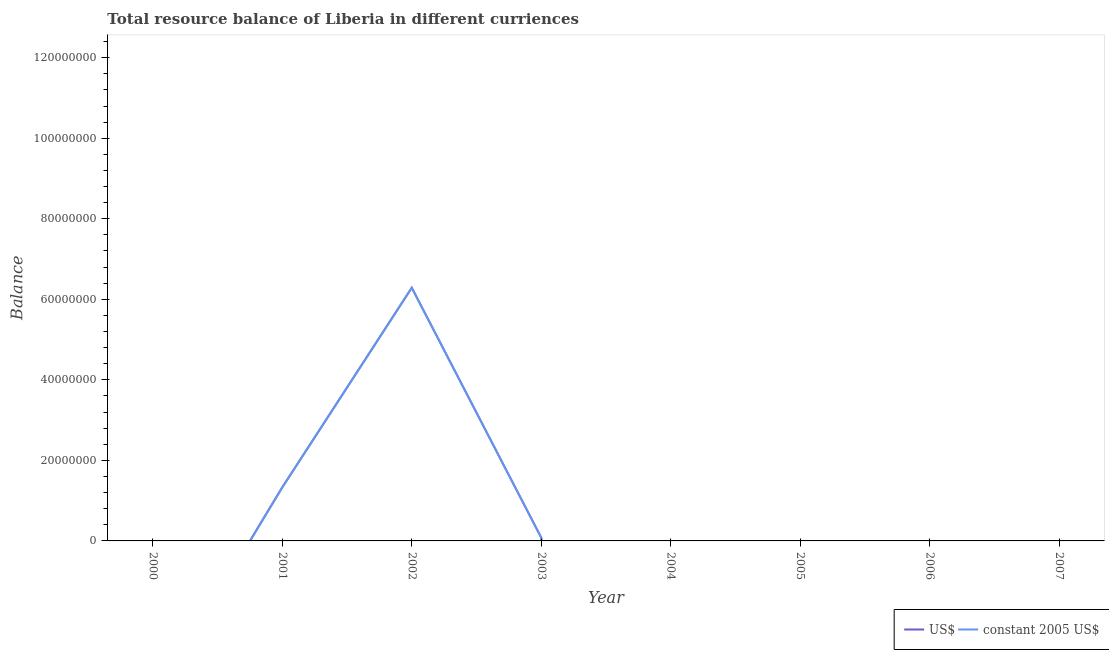Does the line corresponding to resource balance in constant us$ intersect with the line corresponding to resource balance in us$?
Provide a succinct answer. Yes. What is the resource balance in constant us$ in 2007?
Offer a very short reply. 0. Across all years, what is the maximum resource balance in constant us$?
Keep it short and to the point. 6.29e+07. In which year was the resource balance in us$ maximum?
Ensure brevity in your answer.  2002. What is the total resource balance in constant us$ in the graph?
Ensure brevity in your answer.  7.70e+07. What is the difference between the resource balance in us$ in 2001 and that in 2003?
Provide a short and direct response. 1.25e+07. What is the average resource balance in constant us$ per year?
Keep it short and to the point. 9.62e+06. In the year 2002, what is the difference between the resource balance in constant us$ and resource balance in us$?
Keep it short and to the point. 0. What is the ratio of the resource balance in constant us$ in 2002 to that in 2003?
Your answer should be very brief. 77.97. What is the difference between the highest and the second highest resource balance in constant us$?
Offer a terse response. 4.96e+07. What is the difference between the highest and the lowest resource balance in us$?
Give a very brief answer. 6.29e+07. Does the resource balance in us$ monotonically increase over the years?
Your response must be concise. No. Is the resource balance in constant us$ strictly greater than the resource balance in us$ over the years?
Your response must be concise. No. How many years are there in the graph?
Make the answer very short. 8. What is the difference between two consecutive major ticks on the Y-axis?
Offer a very short reply. 2.00e+07. Are the values on the major ticks of Y-axis written in scientific E-notation?
Provide a short and direct response. No. Does the graph contain grids?
Ensure brevity in your answer.  No. Where does the legend appear in the graph?
Your answer should be compact. Bottom right. How many legend labels are there?
Offer a very short reply. 2. What is the title of the graph?
Offer a terse response. Total resource balance of Liberia in different curriences. What is the label or title of the Y-axis?
Provide a short and direct response. Balance. What is the Balance of US$ in 2000?
Your answer should be compact. 0. What is the Balance of constant 2005 US$ in 2000?
Your answer should be compact. 0. What is the Balance in US$ in 2001?
Your answer should be compact. 1.33e+07. What is the Balance of constant 2005 US$ in 2001?
Make the answer very short. 1.33e+07. What is the Balance of US$ in 2002?
Your answer should be very brief. 6.29e+07. What is the Balance of constant 2005 US$ in 2002?
Keep it short and to the point. 6.29e+07. What is the Balance of US$ in 2003?
Your answer should be very brief. 8.06e+05. What is the Balance of constant 2005 US$ in 2003?
Ensure brevity in your answer.  8.06e+05. What is the Balance of constant 2005 US$ in 2004?
Ensure brevity in your answer.  0. What is the Balance of US$ in 2005?
Your answer should be very brief. 0. What is the Balance of constant 2005 US$ in 2005?
Your answer should be compact. 0. What is the Balance of US$ in 2006?
Your answer should be very brief. 0. What is the Balance in constant 2005 US$ in 2006?
Provide a succinct answer. 0. What is the Balance of US$ in 2007?
Your response must be concise. 0. Across all years, what is the maximum Balance of US$?
Your answer should be compact. 6.29e+07. Across all years, what is the maximum Balance of constant 2005 US$?
Give a very brief answer. 6.29e+07. What is the total Balance of US$ in the graph?
Provide a short and direct response. 7.70e+07. What is the total Balance in constant 2005 US$ in the graph?
Offer a very short reply. 7.70e+07. What is the difference between the Balance of US$ in 2001 and that in 2002?
Your response must be concise. -4.96e+07. What is the difference between the Balance of constant 2005 US$ in 2001 and that in 2002?
Offer a terse response. -4.96e+07. What is the difference between the Balance in US$ in 2001 and that in 2003?
Keep it short and to the point. 1.25e+07. What is the difference between the Balance of constant 2005 US$ in 2001 and that in 2003?
Provide a short and direct response. 1.25e+07. What is the difference between the Balance of US$ in 2002 and that in 2003?
Keep it short and to the point. 6.21e+07. What is the difference between the Balance of constant 2005 US$ in 2002 and that in 2003?
Your response must be concise. 6.21e+07. What is the difference between the Balance of US$ in 2001 and the Balance of constant 2005 US$ in 2002?
Give a very brief answer. -4.96e+07. What is the difference between the Balance of US$ in 2001 and the Balance of constant 2005 US$ in 2003?
Make the answer very short. 1.25e+07. What is the difference between the Balance of US$ in 2002 and the Balance of constant 2005 US$ in 2003?
Provide a succinct answer. 6.21e+07. What is the average Balance in US$ per year?
Offer a very short reply. 9.62e+06. What is the average Balance in constant 2005 US$ per year?
Keep it short and to the point. 9.62e+06. In the year 2001, what is the difference between the Balance of US$ and Balance of constant 2005 US$?
Provide a short and direct response. 0. In the year 2003, what is the difference between the Balance in US$ and Balance in constant 2005 US$?
Provide a succinct answer. 0. What is the ratio of the Balance of US$ in 2001 to that in 2002?
Ensure brevity in your answer.  0.21. What is the ratio of the Balance in constant 2005 US$ in 2001 to that in 2002?
Keep it short and to the point. 0.21. What is the ratio of the Balance in US$ in 2001 to that in 2003?
Provide a short and direct response. 16.51. What is the ratio of the Balance in constant 2005 US$ in 2001 to that in 2003?
Give a very brief answer. 16.51. What is the ratio of the Balance of US$ in 2002 to that in 2003?
Make the answer very short. 77.97. What is the ratio of the Balance of constant 2005 US$ in 2002 to that in 2003?
Keep it short and to the point. 77.97. What is the difference between the highest and the second highest Balance in US$?
Your answer should be compact. 4.96e+07. What is the difference between the highest and the second highest Balance in constant 2005 US$?
Keep it short and to the point. 4.96e+07. What is the difference between the highest and the lowest Balance in US$?
Your response must be concise. 6.29e+07. What is the difference between the highest and the lowest Balance in constant 2005 US$?
Provide a succinct answer. 6.29e+07. 